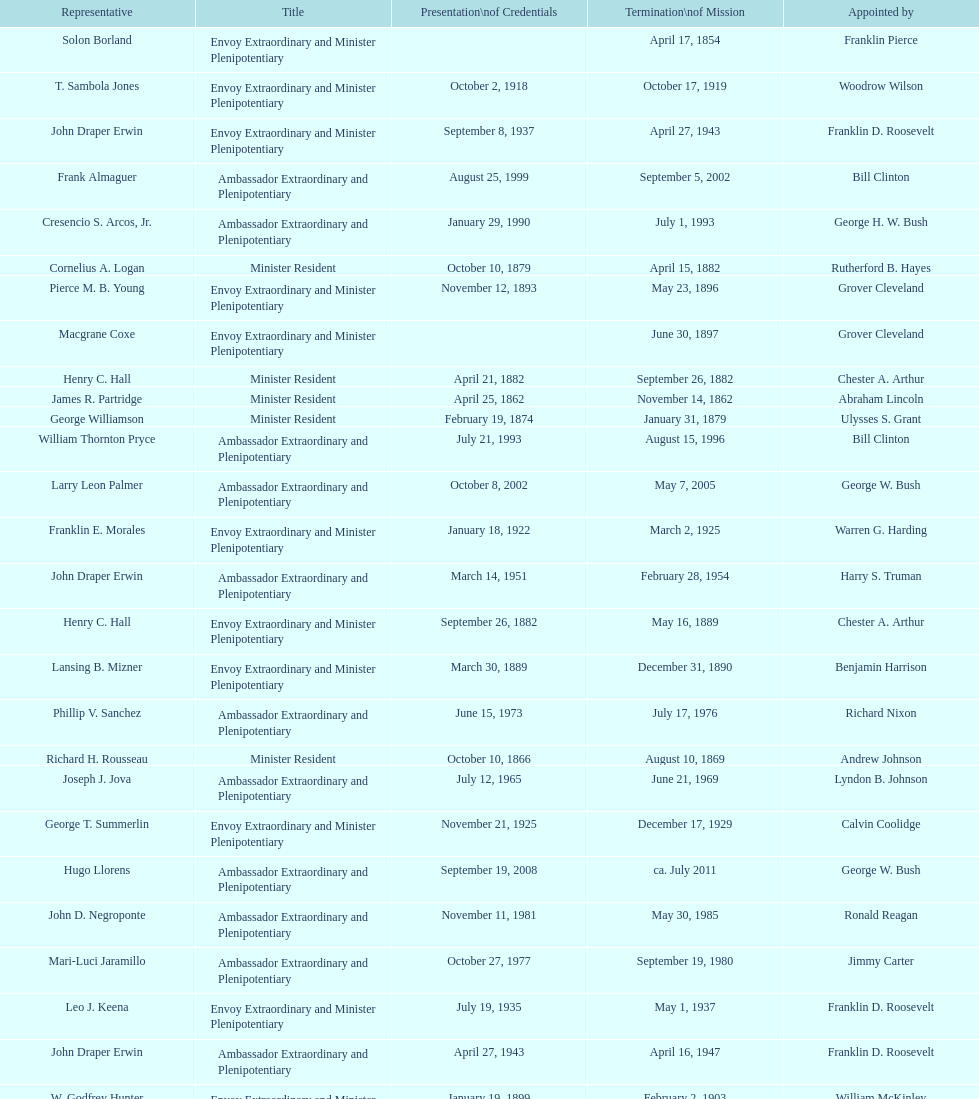Is solon borland a representative? Yes. 